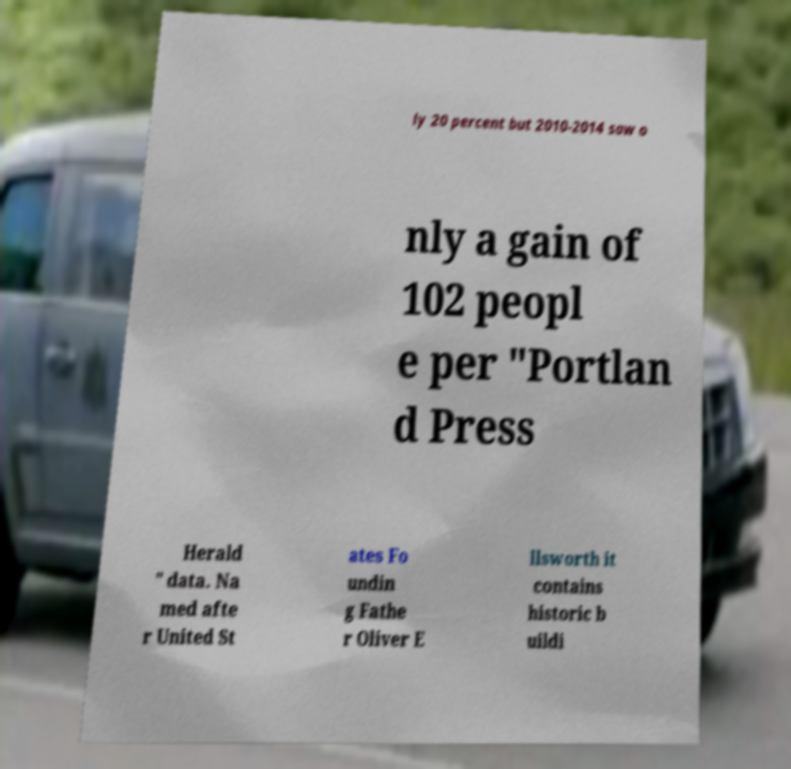Can you accurately transcribe the text from the provided image for me? ly 20 percent but 2010-2014 saw o nly a gain of 102 peopl e per "Portlan d Press Herald " data. Na med afte r United St ates Fo undin g Fathe r Oliver E llsworth it contains historic b uildi 